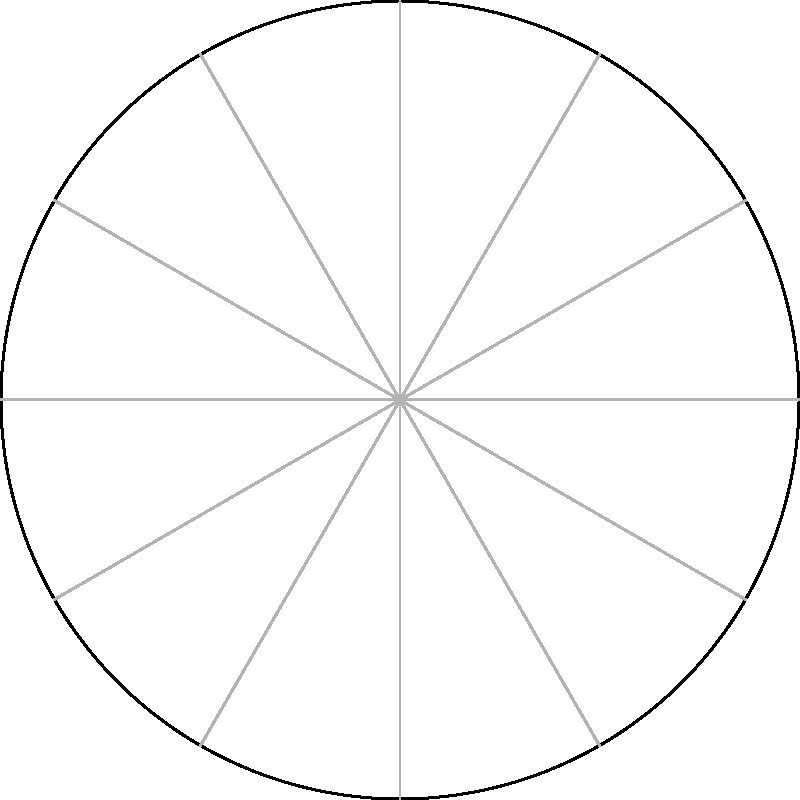On a polar star chart, three celestial objects A, B, and C are located as shown. Object A is at $(45°, 3)$, B at $(150°, 4)$, and C at $(270°, 2)$. Calculate the angular distance between objects A and B to the nearest degree. To find the angular distance between two points on a polar chart, we can use the law of cosines for spherical trigonometry:

1) The formula for angular distance $\theta$ is:
   $$\cos(\theta) = \sin(\phi_1)\sin(\phi_2) + \cos(\phi_1)\cos(\phi_2)\cos(|\lambda_2 - \lambda_1|)$$
   where $\phi$ is the polar angle (90° - declination) and $\lambda$ is the azimuthal angle.

2) For object A: $\phi_1 = 90° - 45° = 45°$, $\lambda_1 = 45°$
   For object B: $\phi_2 = 90° - 150° = -60°$, $\lambda_2 = 150°$

3) Plugging into the formula:
   $$\cos(\theta) = \sin(45°)\sin(-60°) + \cos(45°)\cos(-60°)\cos(|150° - 45°|)$$

4) Simplify:
   $$\cos(\theta) = (\frac{\sqrt{2}}{2})(-\frac{\sqrt{3}}{2}) + (\frac{\sqrt{2}}{2})(\frac{1}{2})\cos(105°)$$

5) Calculate:
   $$\cos(\theta) = -\frac{\sqrt{6}}{4} - \frac{\sqrt{2}}{4}\cos(105°) \approx -0.6830$$

6) Take the inverse cosine and convert to degrees:
   $$\theta = \arccos(-0.6830) \approx 133.1°$$

7) Round to the nearest degree: 133°
Answer: 133° 